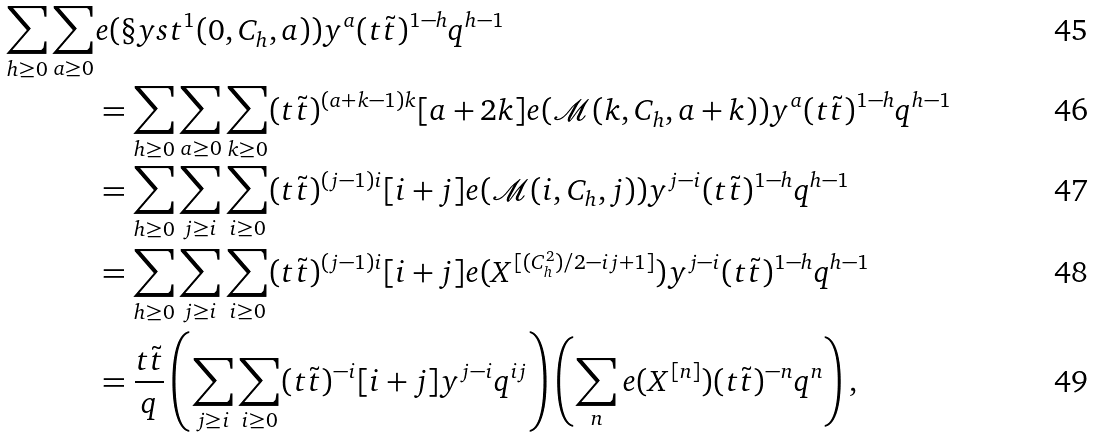<formula> <loc_0><loc_0><loc_500><loc_500>\sum _ { h \geq 0 } \sum _ { a \geq 0 } & e ( \S y s t ^ { 1 } ( 0 , C _ { h } , a ) ) y ^ { a } ( t \tilde { t } ) ^ { 1 - h } q ^ { h - 1 } \\ & = \sum _ { h \geq 0 } \sum _ { a \geq 0 } \sum _ { k \geq 0 } ( t \tilde { t } ) ^ { ( a + k - 1 ) k } [ a + 2 k ] e ( \mathcal { M } ( k , C _ { h } , a + k ) ) y ^ { a } ( t \tilde { t } ) ^ { 1 - h } q ^ { h - 1 } \\ & = \sum _ { h \geq 0 } \sum _ { j \geq i } \sum _ { i \geq 0 } ( t \tilde { t } ) ^ { ( j - 1 ) i } [ i + j ] e ( \mathcal { M } ( i , C _ { h } , j ) ) y ^ { j - i } ( t \tilde { t } ) ^ { 1 - h } q ^ { h - 1 } \\ & = \sum _ { h \geq 0 } \sum _ { j \geq i } \sum _ { i \geq 0 } ( t \tilde { t } ) ^ { ( j - 1 ) i } [ i + j ] e ( X ^ { [ ( C _ { h } ^ { 2 } ) / 2 - i j + 1 ] } ) y ^ { j - i } ( t \tilde { t } ) ^ { 1 - h } q ^ { h - 1 } \\ & = \frac { t \tilde { t } } { q } \left ( \sum _ { j \geq i } \sum _ { i \geq 0 } ( t \tilde { t } ) ^ { - i } [ i + j ] y ^ { j - i } q ^ { i j } \right ) \left ( \sum _ { n } e ( X ^ { [ n ] } ) ( t \tilde { t } ) ^ { - n } q ^ { n } \right ) ,</formula> 